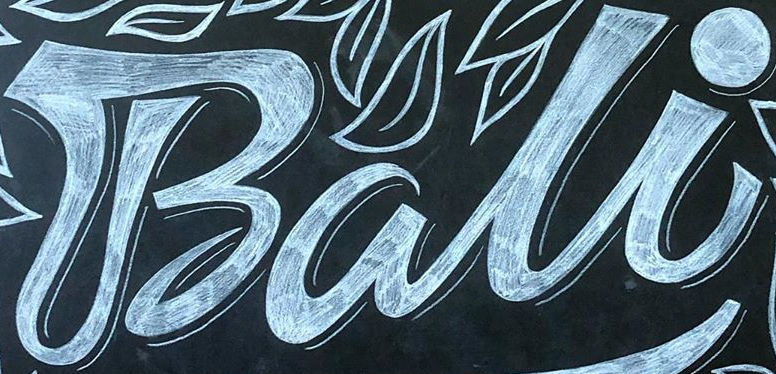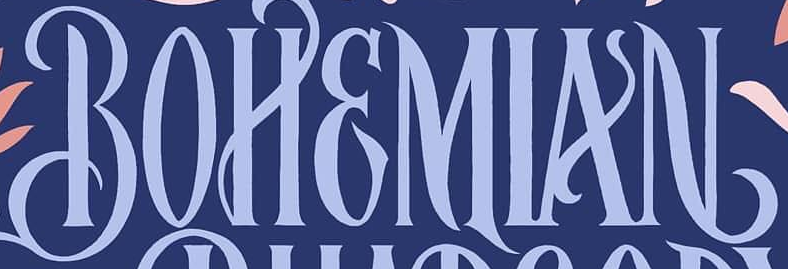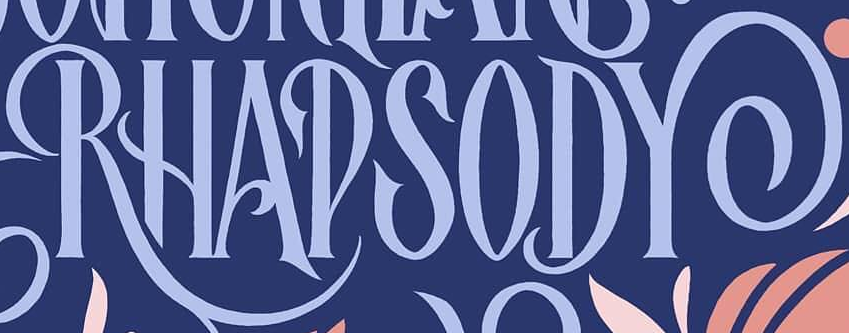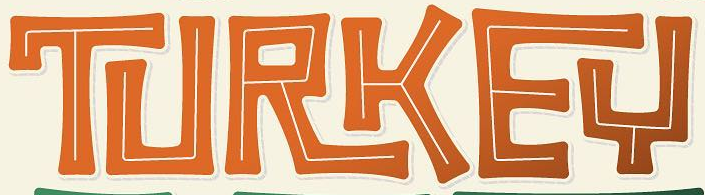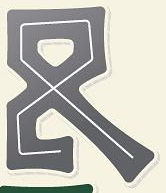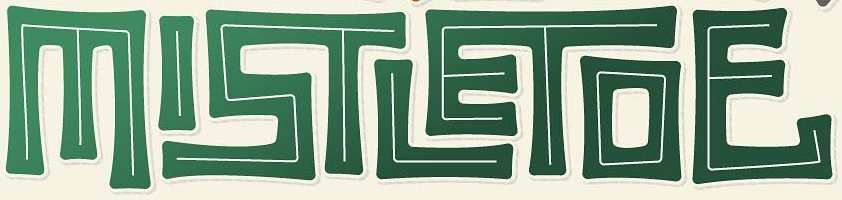What text appears in these images from left to right, separated by a semicolon? Bali; BOHEMIAN; RHAPSODY; TURKEY; &; MISTLETOE 